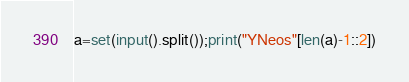Convert code to text. <code><loc_0><loc_0><loc_500><loc_500><_Python_>a=set(input().split());print("YNeos"[len(a)-1::2])</code> 